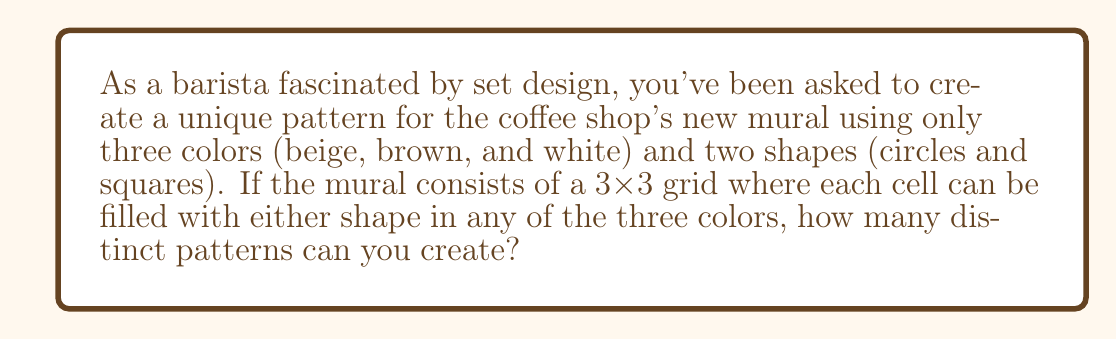Teach me how to tackle this problem. Let's approach this step-by-step:

1) First, we need to understand what our options are for each cell in the 3x3 grid:
   - We have 2 shape choices (circle or square)
   - For each shape, we have 3 color choices (beige, brown, or white)
   - This means for each cell, we have $2 \times 3 = 6$ choices

2) Now, we need to consider how many cells we're filling:
   - The grid is 3x3, so we have 9 cells in total

3) For each cell, we make an independent choice from the 6 options available.

4) In combinatorics, when we have a series of independent choices, we multiply the number of options for each choice.

5) Therefore, the total number of distinct patterns is:

   $$ 6^9 $$

6) Let's calculate this:
   $$ 6^9 = 6 \times 6 \times 6 \times 6 \times 6 \times 6 \times 6 \times 6 \times 6 = 10,077,696 $$

This large number demonstrates how even with limited design elements, we can create a vast number of unique patterns, much like how a set designer can create numerous unique sets with limited props and colors.
Answer: 10,077,696 distinct patterns 